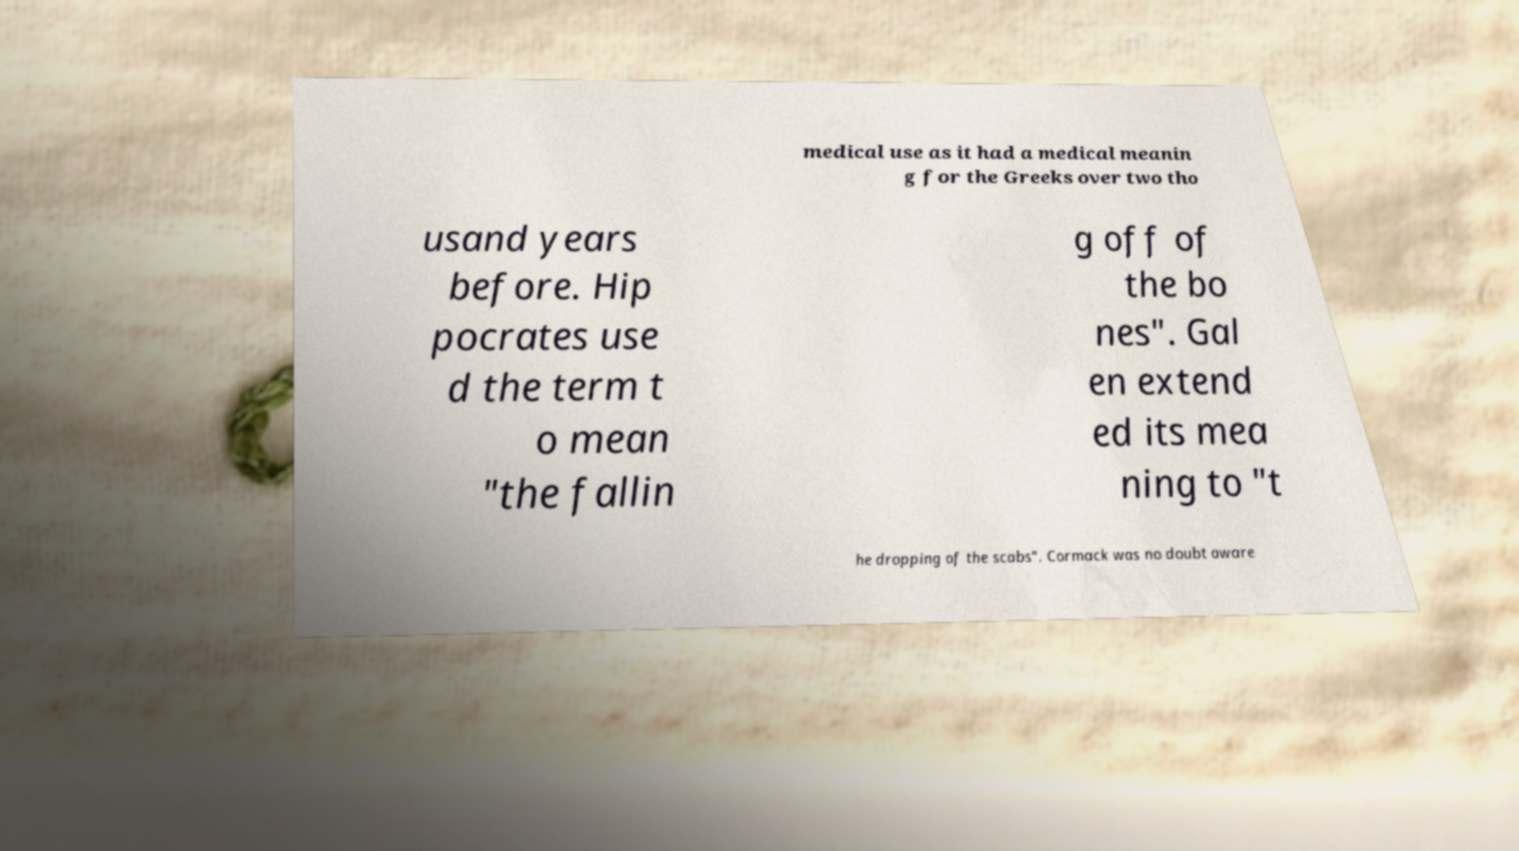Please identify and transcribe the text found in this image. medical use as it had a medical meanin g for the Greeks over two tho usand years before. Hip pocrates use d the term t o mean "the fallin g off of the bo nes". Gal en extend ed its mea ning to "t he dropping of the scabs". Cormack was no doubt aware 